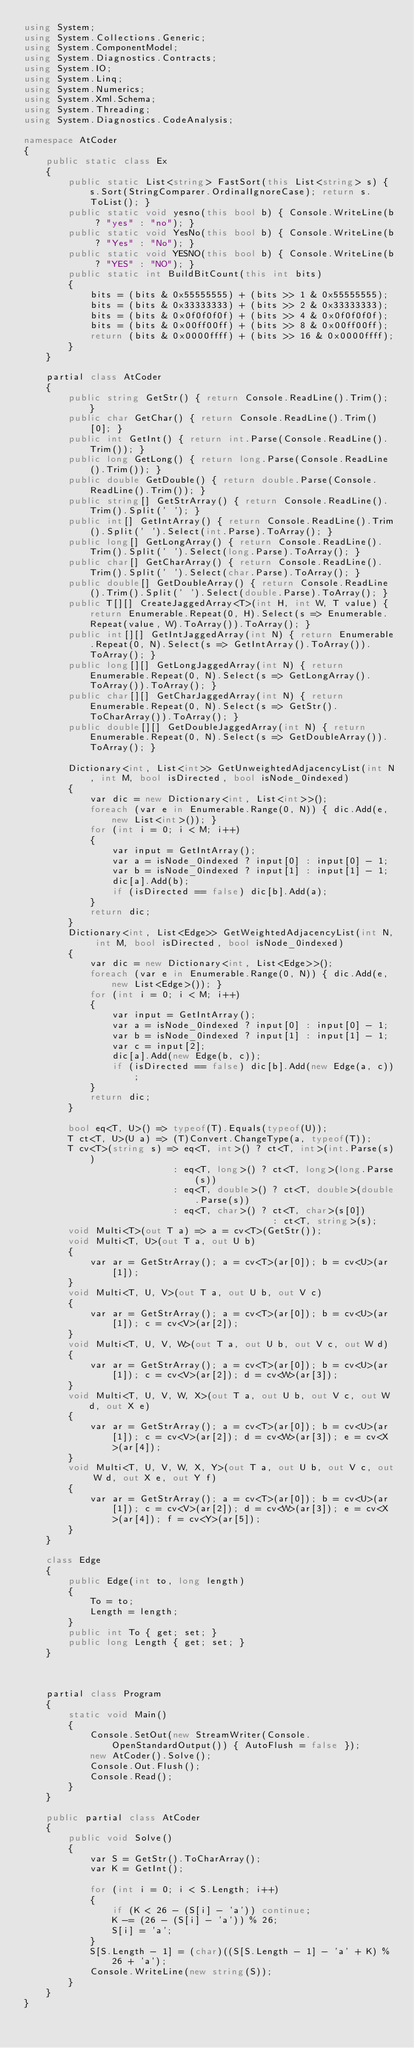<code> <loc_0><loc_0><loc_500><loc_500><_C#_>using System;
using System.Collections.Generic;
using System.ComponentModel;
using System.Diagnostics.Contracts;
using System.IO;
using System.Linq;
using System.Numerics;
using System.Xml.Schema;
using System.Threading;
using System.Diagnostics.CodeAnalysis;

namespace AtCoder
{
    public static class Ex
    {
        public static List<string> FastSort(this List<string> s) { s.Sort(StringComparer.OrdinalIgnoreCase); return s.ToList(); }
        public static void yesno(this bool b) { Console.WriteLine(b ? "yes" : "no"); }
        public static void YesNo(this bool b) { Console.WriteLine(b ? "Yes" : "No"); }
        public static void YESNO(this bool b) { Console.WriteLine(b ? "YES" : "NO"); }
        public static int BuildBitCount(this int bits)
        {
            bits = (bits & 0x55555555) + (bits >> 1 & 0x55555555);
            bits = (bits & 0x33333333) + (bits >> 2 & 0x33333333);
            bits = (bits & 0x0f0f0f0f) + (bits >> 4 & 0x0f0f0f0f);
            bits = (bits & 0x00ff00ff) + (bits >> 8 & 0x00ff00ff);
            return (bits & 0x0000ffff) + (bits >> 16 & 0x0000ffff);
        }
    }

    partial class AtCoder
    {
        public string GetStr() { return Console.ReadLine().Trim(); }
        public char GetChar() { return Console.ReadLine().Trim()[0]; }
        public int GetInt() { return int.Parse(Console.ReadLine().Trim()); }
        public long GetLong() { return long.Parse(Console.ReadLine().Trim()); }
        public double GetDouble() { return double.Parse(Console.ReadLine().Trim()); }
        public string[] GetStrArray() { return Console.ReadLine().Trim().Split(' '); }
        public int[] GetIntArray() { return Console.ReadLine().Trim().Split(' ').Select(int.Parse).ToArray(); }
        public long[] GetLongArray() { return Console.ReadLine().Trim().Split(' ').Select(long.Parse).ToArray(); }
        public char[] GetCharArray() { return Console.ReadLine().Trim().Split(' ').Select(char.Parse).ToArray(); }
        public double[] GetDoubleArray() { return Console.ReadLine().Trim().Split(' ').Select(double.Parse).ToArray(); }
        public T[][] CreateJaggedArray<T>(int H, int W, T value) { return Enumerable.Repeat(0, H).Select(s => Enumerable.Repeat(value, W).ToArray()).ToArray(); }
        public int[][] GetIntJaggedArray(int N) { return Enumerable.Repeat(0, N).Select(s => GetIntArray().ToArray()).ToArray(); }
        public long[][] GetLongJaggedArray(int N) { return Enumerable.Repeat(0, N).Select(s => GetLongArray().ToArray()).ToArray(); }
        public char[][] GetCharJaggedArray(int N) { return Enumerable.Repeat(0, N).Select(s => GetStr().ToCharArray()).ToArray(); }
        public double[][] GetDoubleJaggedArray(int N) { return Enumerable.Repeat(0, N).Select(s => GetDoubleArray()).ToArray(); }

        Dictionary<int, List<int>> GetUnweightedAdjacencyList(int N, int M, bool isDirected, bool isNode_0indexed)
        {
            var dic = new Dictionary<int, List<int>>();
            foreach (var e in Enumerable.Range(0, N)) { dic.Add(e, new List<int>()); }
            for (int i = 0; i < M; i++)
            {
                var input = GetIntArray();
                var a = isNode_0indexed ? input[0] : input[0] - 1;
                var b = isNode_0indexed ? input[1] : input[1] - 1;
                dic[a].Add(b);
                if (isDirected == false) dic[b].Add(a);
            }
            return dic;
        }
        Dictionary<int, List<Edge>> GetWeightedAdjacencyList(int N, int M, bool isDirected, bool isNode_0indexed)
        {
            var dic = new Dictionary<int, List<Edge>>();
            foreach (var e in Enumerable.Range(0, N)) { dic.Add(e, new List<Edge>()); }
            for (int i = 0; i < M; i++)
            {
                var input = GetIntArray();
                var a = isNode_0indexed ? input[0] : input[0] - 1;
                var b = isNode_0indexed ? input[1] : input[1] - 1;
                var c = input[2];
                dic[a].Add(new Edge(b, c));
                if (isDirected == false) dic[b].Add(new Edge(a, c));
            }
            return dic;
        }

        bool eq<T, U>() => typeof(T).Equals(typeof(U));
        T ct<T, U>(U a) => (T)Convert.ChangeType(a, typeof(T));
        T cv<T>(string s) => eq<T, int>() ? ct<T, int>(int.Parse(s))
                           : eq<T, long>() ? ct<T, long>(long.Parse(s))
                           : eq<T, double>() ? ct<T, double>(double.Parse(s))
                           : eq<T, char>() ? ct<T, char>(s[0])
                                             : ct<T, string>(s);
        void Multi<T>(out T a) => a = cv<T>(GetStr());
        void Multi<T, U>(out T a, out U b)
        {
            var ar = GetStrArray(); a = cv<T>(ar[0]); b = cv<U>(ar[1]);
        }
        void Multi<T, U, V>(out T a, out U b, out V c)
        {
            var ar = GetStrArray(); a = cv<T>(ar[0]); b = cv<U>(ar[1]); c = cv<V>(ar[2]);
        }
        void Multi<T, U, V, W>(out T a, out U b, out V c, out W d)
        {
            var ar = GetStrArray(); a = cv<T>(ar[0]); b = cv<U>(ar[1]); c = cv<V>(ar[2]); d = cv<W>(ar[3]);
        }
        void Multi<T, U, V, W, X>(out T a, out U b, out V c, out W d, out X e)
        {
            var ar = GetStrArray(); a = cv<T>(ar[0]); b = cv<U>(ar[1]); c = cv<V>(ar[2]); d = cv<W>(ar[3]); e = cv<X>(ar[4]);
        }
        void Multi<T, U, V, W, X, Y>(out T a, out U b, out V c, out W d, out X e, out Y f)
        {
            var ar = GetStrArray(); a = cv<T>(ar[0]); b = cv<U>(ar[1]); c = cv<V>(ar[2]); d = cv<W>(ar[3]); e = cv<X>(ar[4]); f = cv<Y>(ar[5]);
        }
    }

    class Edge
    {
        public Edge(int to, long length)
        {
            To = to;
            Length = length;
        }
        public int To { get; set; }
        public long Length { get; set; }
    }



    partial class Program
    {
        static void Main()
        {
            Console.SetOut(new StreamWriter(Console.OpenStandardOutput()) { AutoFlush = false });
            new AtCoder().Solve();
            Console.Out.Flush();
            Console.Read();
        }
    }

    public partial class AtCoder
    {
        public void Solve()
        {
            var S = GetStr().ToCharArray();
            var K = GetInt();

            for (int i = 0; i < S.Length; i++)
            {
                if (K < 26 - (S[i] - 'a')) continue;
                K -= (26 - (S[i] - 'a')) % 26;
                S[i] = 'a';
            }
            S[S.Length - 1] = (char)((S[S.Length - 1] - 'a' + K) % 26 + 'a');
            Console.WriteLine(new string(S));
        }
    }
}
</code> 